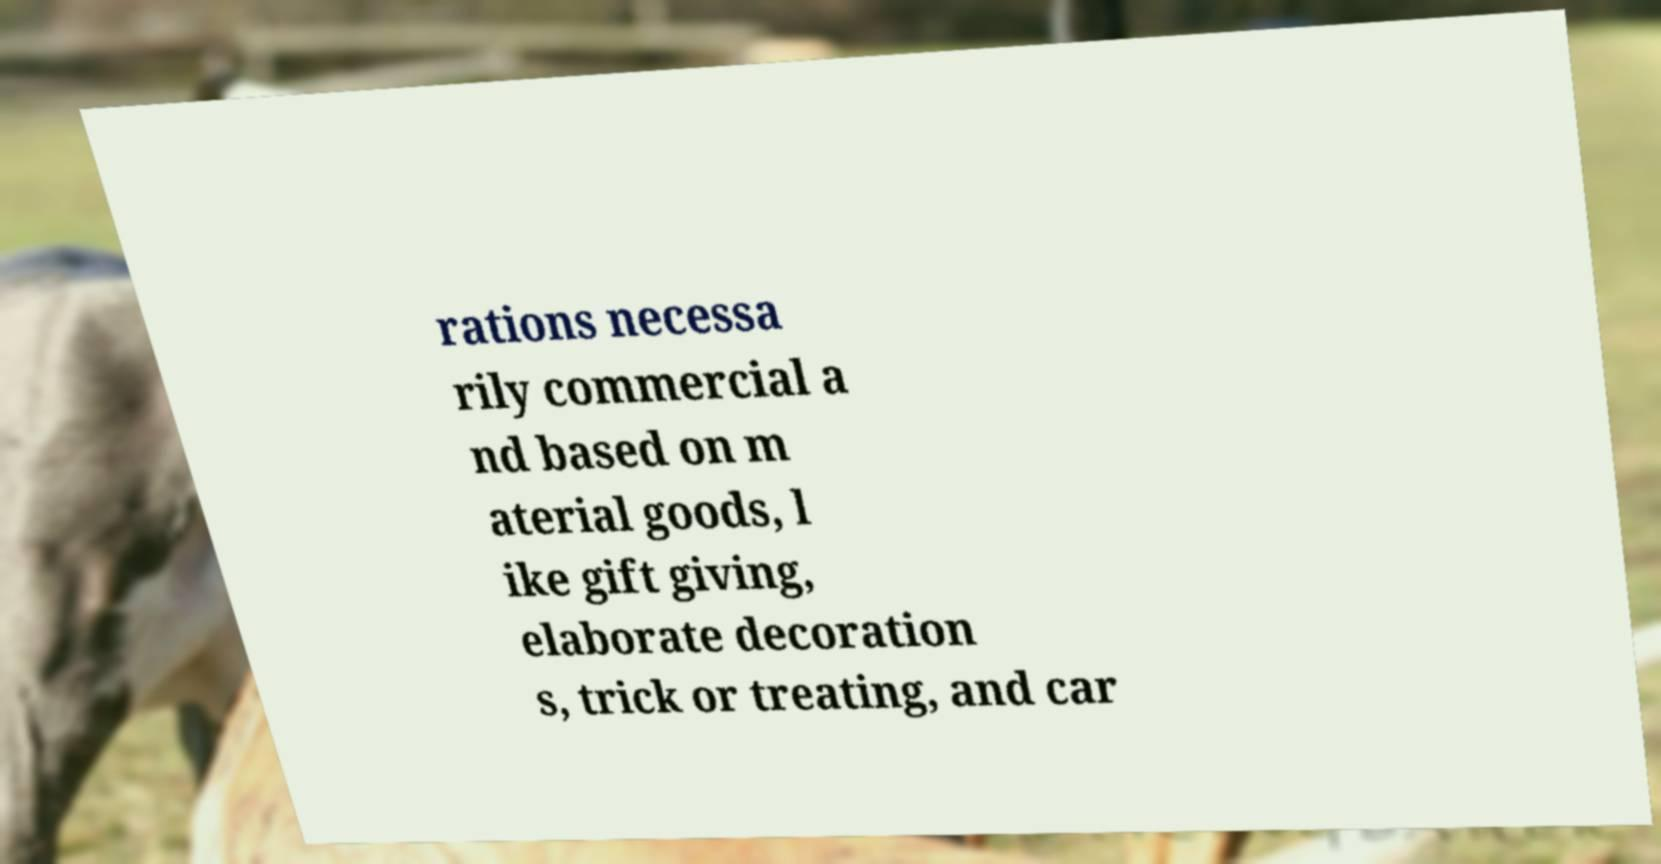Can you accurately transcribe the text from the provided image for me? rations necessa rily commercial a nd based on m aterial goods, l ike gift giving, elaborate decoration s, trick or treating, and car 